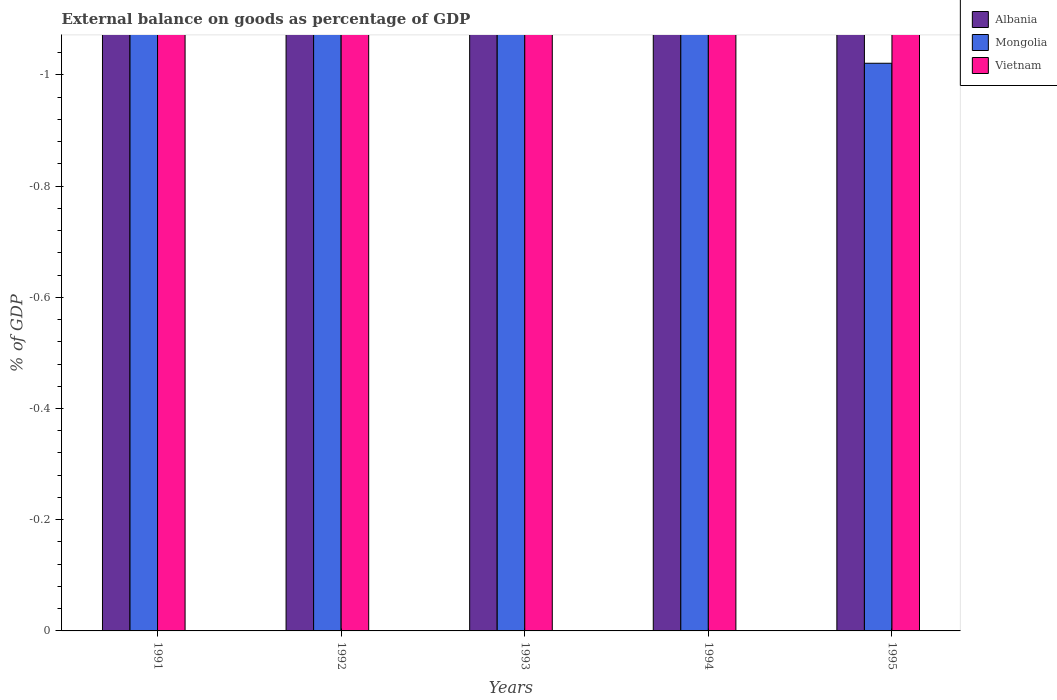How many different coloured bars are there?
Your answer should be very brief. 0. How many bars are there on the 2nd tick from the right?
Your response must be concise. 0. What is the label of the 4th group of bars from the left?
Keep it short and to the point. 1994. In how many cases, is the number of bars for a given year not equal to the number of legend labels?
Ensure brevity in your answer.  5. Across all years, what is the minimum external balance on goods as percentage of GDP in Mongolia?
Offer a very short reply. 0. What is the total external balance on goods as percentage of GDP in Vietnam in the graph?
Offer a terse response. 0. What is the difference between the external balance on goods as percentage of GDP in Mongolia in 1992 and the external balance on goods as percentage of GDP in Vietnam in 1995?
Ensure brevity in your answer.  0. Is it the case that in every year, the sum of the external balance on goods as percentage of GDP in Vietnam and external balance on goods as percentage of GDP in Albania is greater than the external balance on goods as percentage of GDP in Mongolia?
Provide a succinct answer. No. How many bars are there?
Provide a succinct answer. 0. What is the difference between two consecutive major ticks on the Y-axis?
Offer a terse response. 0.2. Are the values on the major ticks of Y-axis written in scientific E-notation?
Keep it short and to the point. No. How many legend labels are there?
Your answer should be compact. 3. How are the legend labels stacked?
Give a very brief answer. Vertical. What is the title of the graph?
Offer a very short reply. External balance on goods as percentage of GDP. Does "Small states" appear as one of the legend labels in the graph?
Your answer should be very brief. No. What is the label or title of the Y-axis?
Provide a succinct answer. % of GDP. What is the % of GDP in Mongolia in 1992?
Keep it short and to the point. 0. What is the % of GDP of Vietnam in 1992?
Offer a very short reply. 0. What is the % of GDP of Mongolia in 1995?
Keep it short and to the point. 0. What is the average % of GDP of Albania per year?
Offer a terse response. 0. What is the average % of GDP in Vietnam per year?
Provide a succinct answer. 0. 